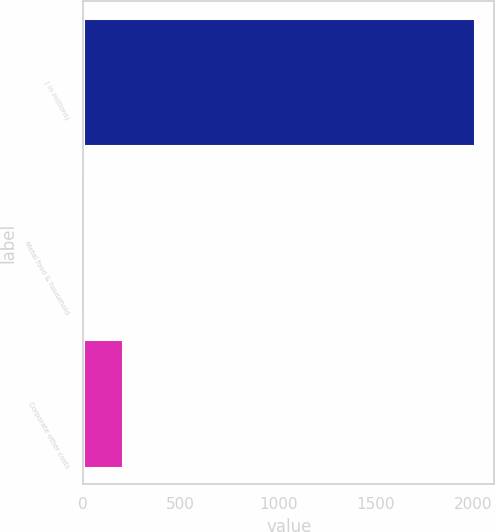Convert chart to OTSL. <chart><loc_0><loc_0><loc_500><loc_500><bar_chart><fcel>( in millions)<fcel>Metal food & household<fcel>Corporate other costs<nl><fcel>2008<fcel>1.6<fcel>202.24<nl></chart> 